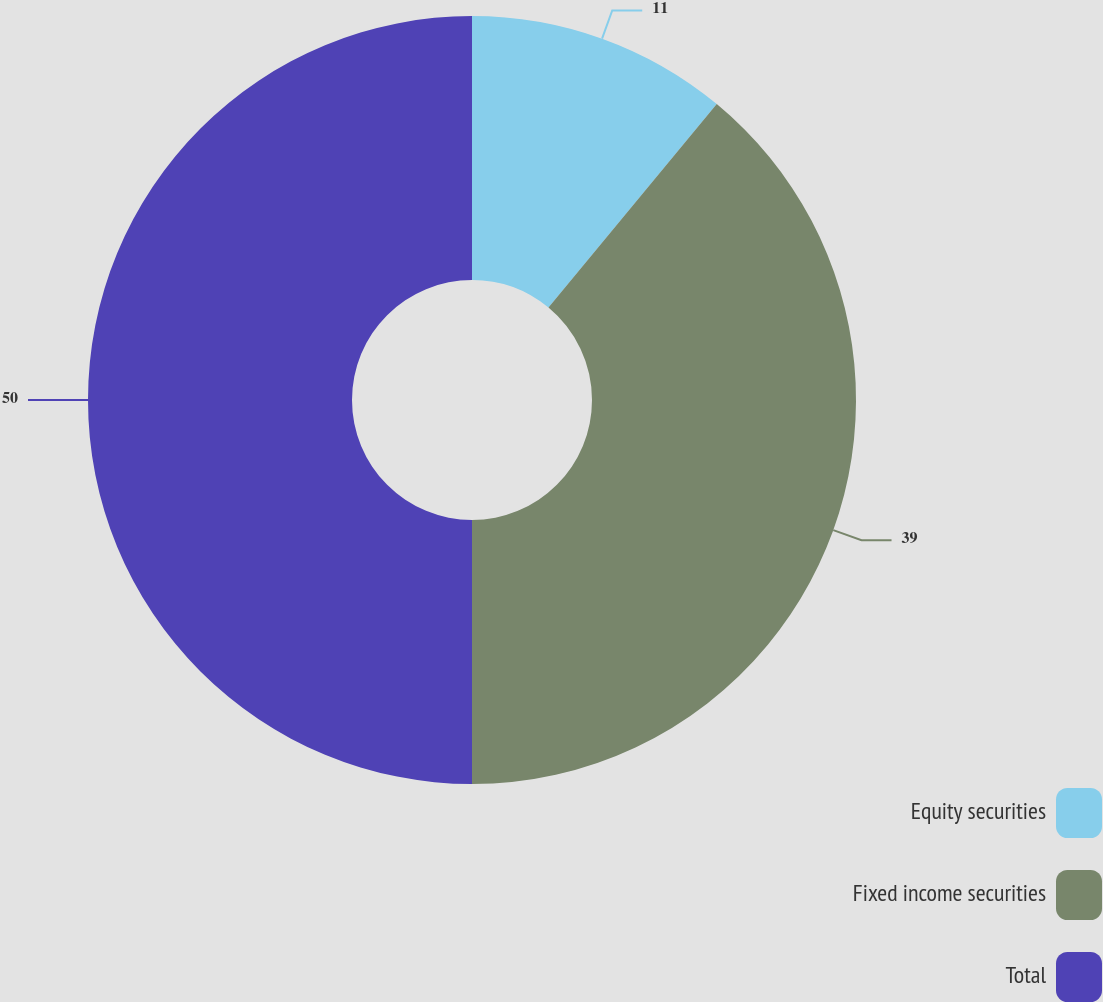Convert chart to OTSL. <chart><loc_0><loc_0><loc_500><loc_500><pie_chart><fcel>Equity securities<fcel>Fixed income securities<fcel>Total<nl><fcel>11.0%<fcel>39.0%<fcel>50.0%<nl></chart> 